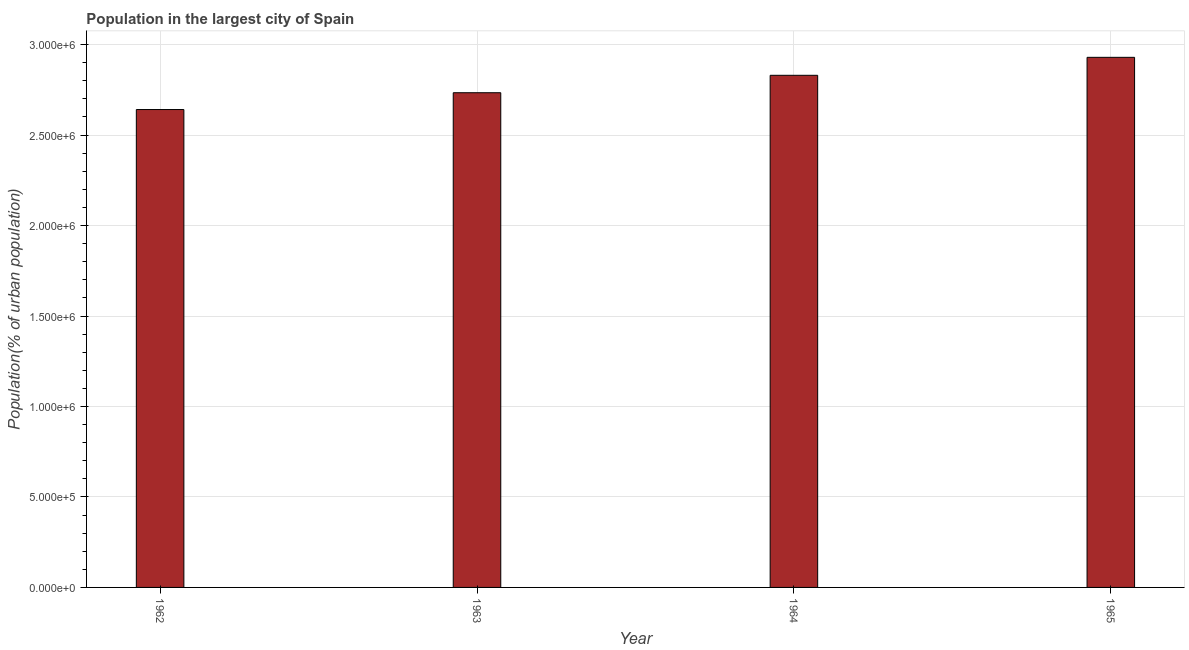What is the title of the graph?
Give a very brief answer. Population in the largest city of Spain. What is the label or title of the X-axis?
Offer a very short reply. Year. What is the label or title of the Y-axis?
Your response must be concise. Population(% of urban population). What is the population in largest city in 1965?
Offer a very short reply. 2.93e+06. Across all years, what is the maximum population in largest city?
Ensure brevity in your answer.  2.93e+06. Across all years, what is the minimum population in largest city?
Make the answer very short. 2.64e+06. In which year was the population in largest city maximum?
Your response must be concise. 1965. In which year was the population in largest city minimum?
Offer a very short reply. 1962. What is the sum of the population in largest city?
Your answer should be compact. 1.11e+07. What is the difference between the population in largest city in 1963 and 1964?
Your answer should be very brief. -9.63e+04. What is the average population in largest city per year?
Your answer should be compact. 2.78e+06. What is the median population in largest city?
Offer a very short reply. 2.78e+06. In how many years, is the population in largest city greater than 1900000 %?
Your response must be concise. 4. Do a majority of the years between 1964 and 1963 (inclusive) have population in largest city greater than 1600000 %?
Ensure brevity in your answer.  No. Is the population in largest city in 1962 less than that in 1964?
Provide a succinct answer. Yes. Is the difference between the population in largest city in 1964 and 1965 greater than the difference between any two years?
Keep it short and to the point. No. What is the difference between the highest and the second highest population in largest city?
Offer a terse response. 9.94e+04. What is the difference between the highest and the lowest population in largest city?
Provide a short and direct response. 2.88e+05. In how many years, is the population in largest city greater than the average population in largest city taken over all years?
Your response must be concise. 2. Are all the bars in the graph horizontal?
Keep it short and to the point. No. How many years are there in the graph?
Ensure brevity in your answer.  4. What is the difference between two consecutive major ticks on the Y-axis?
Offer a terse response. 5.00e+05. What is the Population(% of urban population) in 1962?
Make the answer very short. 2.64e+06. What is the Population(% of urban population) of 1963?
Offer a terse response. 2.73e+06. What is the Population(% of urban population) in 1964?
Provide a succinct answer. 2.83e+06. What is the Population(% of urban population) in 1965?
Your answer should be very brief. 2.93e+06. What is the difference between the Population(% of urban population) in 1962 and 1963?
Offer a very short reply. -9.29e+04. What is the difference between the Population(% of urban population) in 1962 and 1964?
Your answer should be compact. -1.89e+05. What is the difference between the Population(% of urban population) in 1962 and 1965?
Provide a short and direct response. -2.88e+05. What is the difference between the Population(% of urban population) in 1963 and 1964?
Your answer should be compact. -9.63e+04. What is the difference between the Population(% of urban population) in 1963 and 1965?
Provide a short and direct response. -1.96e+05. What is the difference between the Population(% of urban population) in 1964 and 1965?
Provide a succinct answer. -9.94e+04. What is the ratio of the Population(% of urban population) in 1962 to that in 1964?
Give a very brief answer. 0.93. What is the ratio of the Population(% of urban population) in 1962 to that in 1965?
Ensure brevity in your answer.  0.9. What is the ratio of the Population(% of urban population) in 1963 to that in 1965?
Provide a short and direct response. 0.93. 